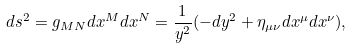<formula> <loc_0><loc_0><loc_500><loc_500>d s ^ { 2 } = g _ { M N } d x ^ { M } d x ^ { N } = \frac { 1 } { y ^ { 2 } } ( - d y ^ { 2 } + \eta _ { \mu \nu } d x ^ { \mu } d x ^ { \nu } ) ,</formula> 